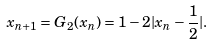Convert formula to latex. <formula><loc_0><loc_0><loc_500><loc_500>x _ { n + 1 } = G _ { 2 } ( x _ { n } ) = 1 - 2 | x _ { n } - \frac { 1 } { 2 } | .</formula> 